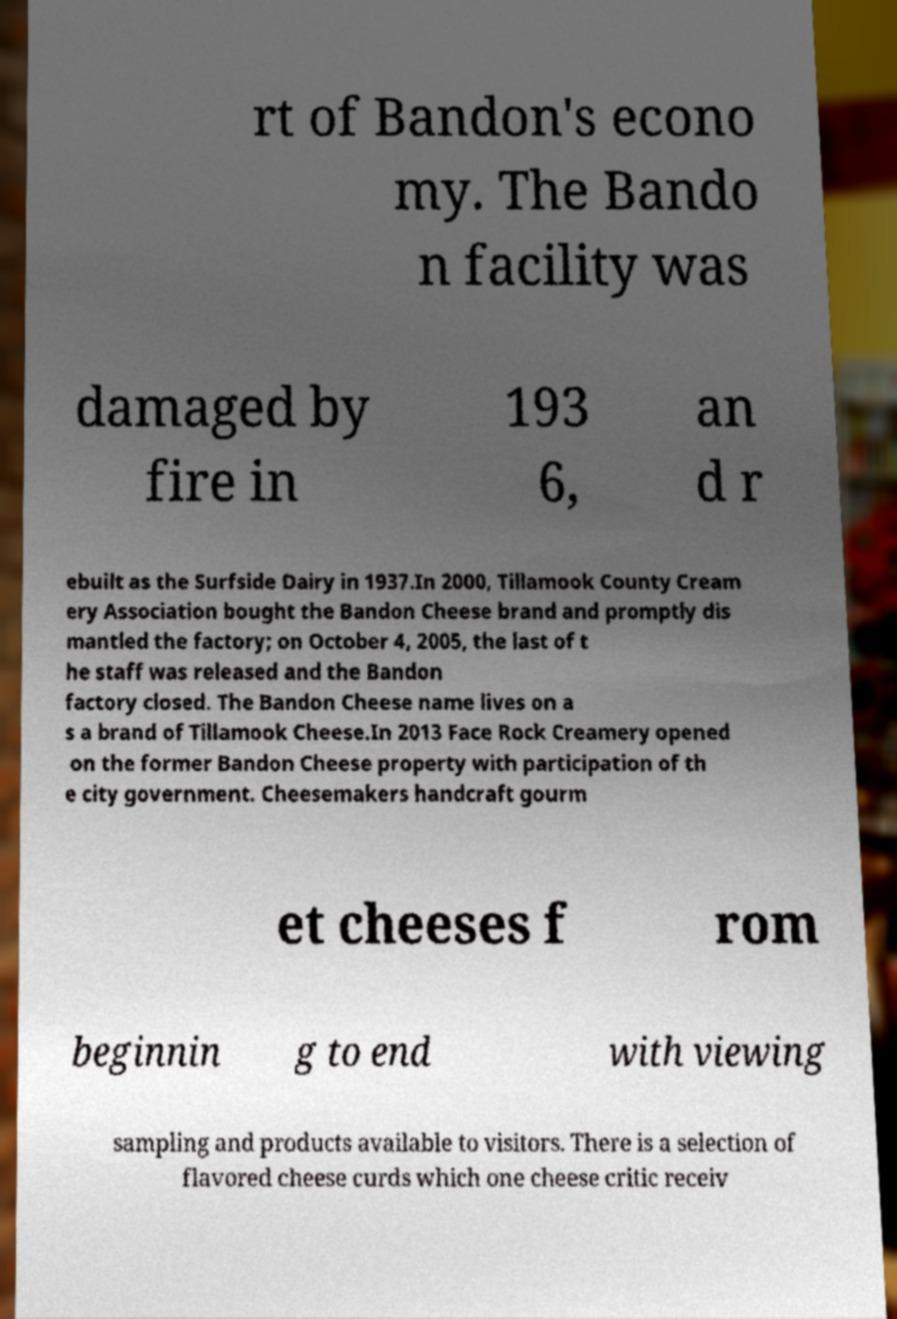Could you assist in decoding the text presented in this image and type it out clearly? rt of Bandon's econo my. The Bando n facility was damaged by fire in 193 6, an d r ebuilt as the Surfside Dairy in 1937.In 2000, Tillamook County Cream ery Association bought the Bandon Cheese brand and promptly dis mantled the factory; on October 4, 2005, the last of t he staff was released and the Bandon factory closed. The Bandon Cheese name lives on a s a brand of Tillamook Cheese.In 2013 Face Rock Creamery opened on the former Bandon Cheese property with participation of th e city government. Cheesemakers handcraft gourm et cheeses f rom beginnin g to end with viewing sampling and products available to visitors. There is a selection of flavored cheese curds which one cheese critic receiv 